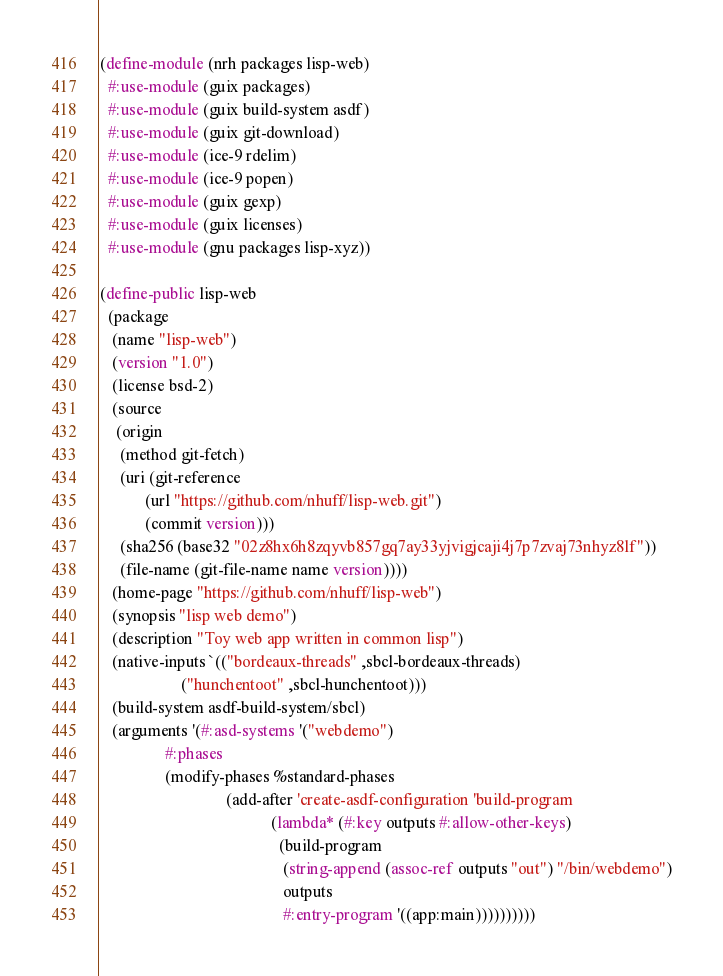Convert code to text. <code><loc_0><loc_0><loc_500><loc_500><_Scheme_>(define-module (nrh packages lisp-web)
  #:use-module (guix packages)
  #:use-module (guix build-system asdf)
  #:use-module (guix git-download)
  #:use-module (ice-9 rdelim)
  #:use-module (ice-9 popen)
  #:use-module (guix gexp)
  #:use-module (guix licenses)
  #:use-module (gnu packages lisp-xyz))

(define-public lisp-web
  (package
   (name "lisp-web")
   (version "1.0")
   (license bsd-2)
   (source
    (origin
     (method git-fetch)
     (uri (git-reference
           (url "https://github.com/nhuff/lisp-web.git")
           (commit version)))
     (sha256 (base32 "02z8hx6h8zqyvb857gq7ay33yjvigjcaji4j7p7zvaj73nhyz8lf"))
     (file-name (git-file-name name version))))
   (home-page "https://github.com/nhuff/lisp-web")
   (synopsis "lisp web demo")
   (description "Toy web app written in common lisp")
   (native-inputs `(("bordeaux-threads" ,sbcl-bordeaux-threads)
                    ("hunchentoot" ,sbcl-hunchentoot)))
   (build-system asdf-build-system/sbcl)
   (arguments '(#:asd-systems '("webdemo")
                #:phases
                (modify-phases %standard-phases
                               (add-after 'create-asdf-configuration 'build-program
                                          (lambda* (#:key outputs #:allow-other-keys)
                                            (build-program
                                             (string-append (assoc-ref outputs "out") "/bin/webdemo")
                                             outputs
                                             #:entry-program '((app:main))))))))))
</code> 